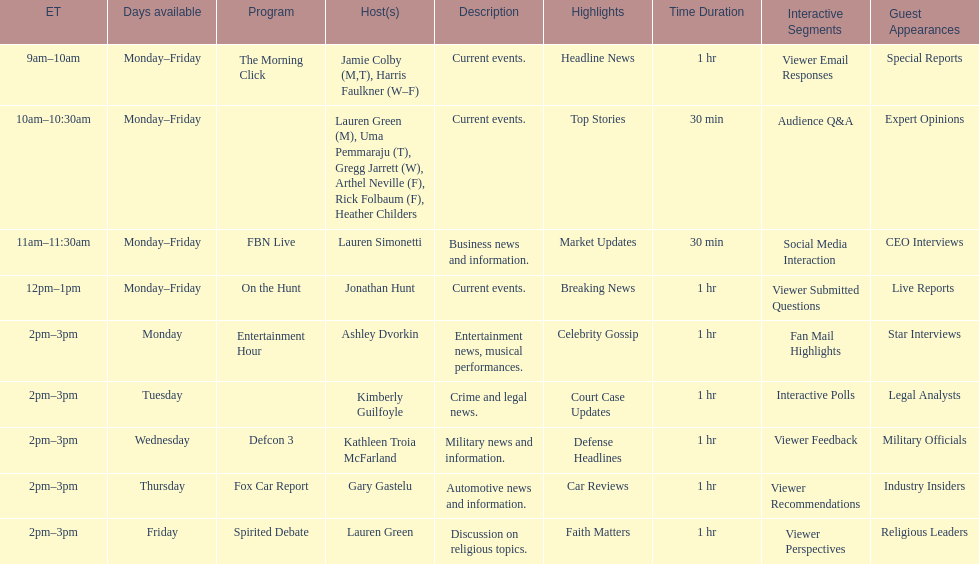Over how many days weekly is fbn live available? 5. 